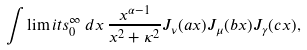Convert formula to latex. <formula><loc_0><loc_0><loc_500><loc_500>\int \lim i t s _ { 0 } ^ { \infty } \, d x \, \frac { x ^ { \alpha - 1 } } { x ^ { 2 } + \kappa ^ { 2 } } J _ { \nu } ( a x ) J _ { \mu } ( b x ) J _ { \gamma } ( c x ) ,</formula> 